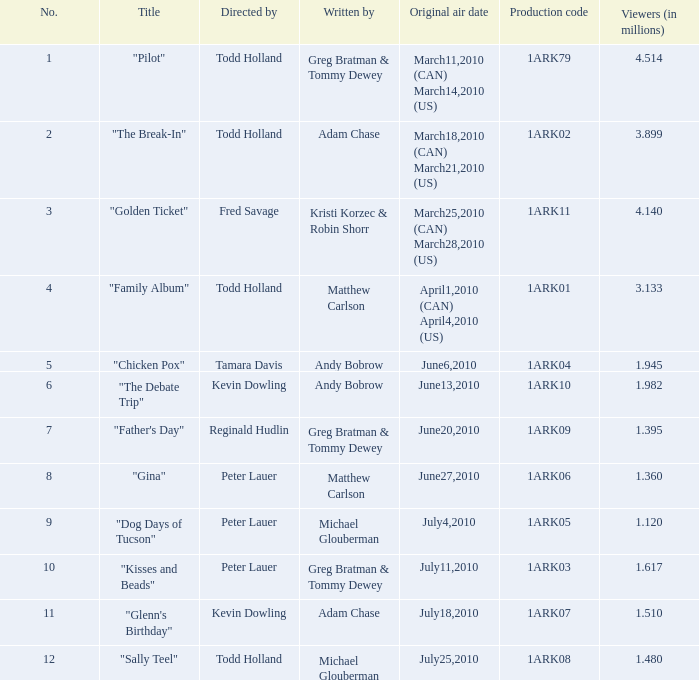What is the initial air date for production code 1ark79? March11,2010 (CAN) March14,2010 (US). 